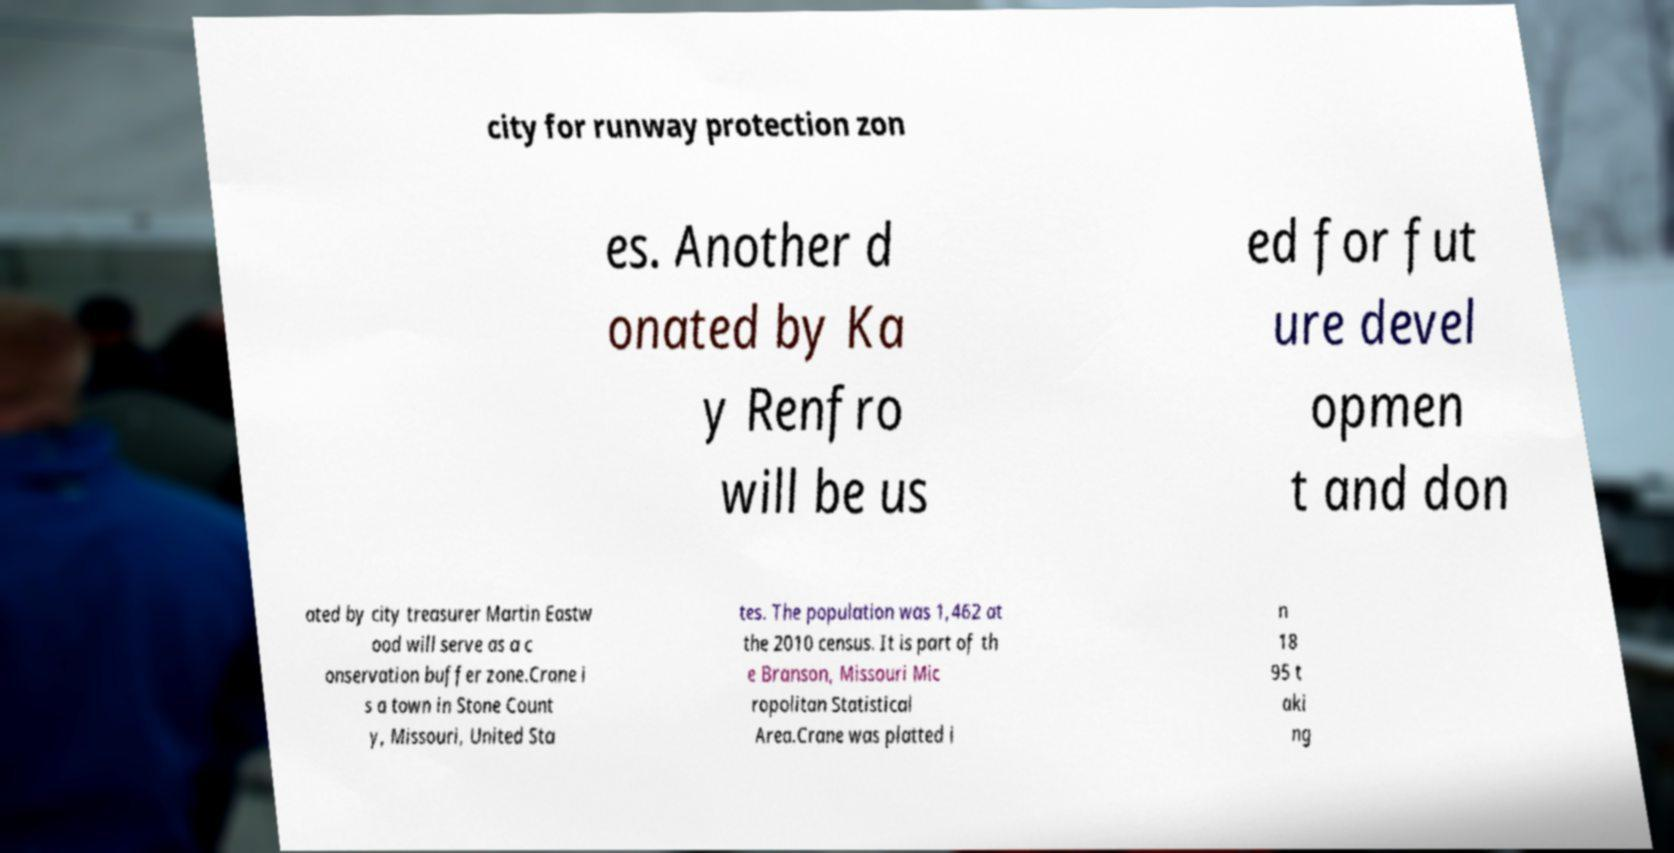For documentation purposes, I need the text within this image transcribed. Could you provide that? city for runway protection zon es. Another d onated by Ka y Renfro will be us ed for fut ure devel opmen t and don ated by city treasurer Martin Eastw ood will serve as a c onservation buffer zone.Crane i s a town in Stone Count y, Missouri, United Sta tes. The population was 1,462 at the 2010 census. It is part of th e Branson, Missouri Mic ropolitan Statistical Area.Crane was platted i n 18 95 t aki ng 